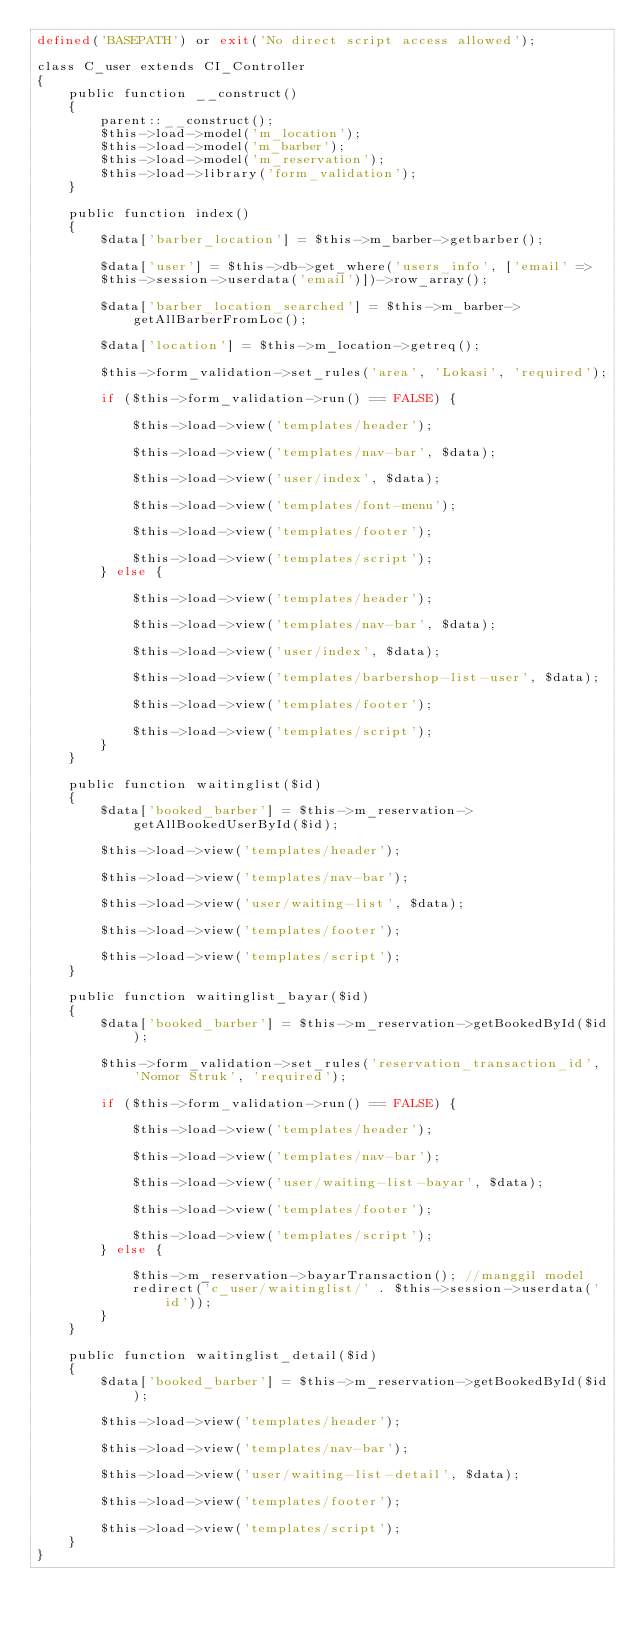<code> <loc_0><loc_0><loc_500><loc_500><_PHP_>defined('BASEPATH') or exit('No direct script access allowed');

class C_user extends CI_Controller
{
    public function __construct()
    {
        parent::__construct();
        $this->load->model('m_location');
        $this->load->model('m_barber');
        $this->load->model('m_reservation');
        $this->load->library('form_validation');
    }

    public function index()
    {
        $data['barber_location'] = $this->m_barber->getbarber();

        $data['user'] = $this->db->get_where('users_info', ['email' =>
        $this->session->userdata('email')])->row_array();

        $data['barber_location_searched'] = $this->m_barber->getAllBarberFromLoc();

        $data['location'] = $this->m_location->getreq();

        $this->form_validation->set_rules('area', 'Lokasi', 'required');

        if ($this->form_validation->run() == FALSE) {

            $this->load->view('templates/header');

            $this->load->view('templates/nav-bar', $data);

            $this->load->view('user/index', $data);

            $this->load->view('templates/font-menu');

            $this->load->view('templates/footer');

            $this->load->view('templates/script');
        } else {

            $this->load->view('templates/header');

            $this->load->view('templates/nav-bar', $data);

            $this->load->view('user/index', $data);

            $this->load->view('templates/barbershop-list-user', $data);

            $this->load->view('templates/footer');

            $this->load->view('templates/script');
        }
    }

    public function waitinglist($id)
    {
        $data['booked_barber'] = $this->m_reservation->getAllBookedUserById($id);

        $this->load->view('templates/header');

        $this->load->view('templates/nav-bar');

        $this->load->view('user/waiting-list', $data);

        $this->load->view('templates/footer');

        $this->load->view('templates/script');
    }

    public function waitinglist_bayar($id)
    {
        $data['booked_barber'] = $this->m_reservation->getBookedById($id);

        $this->form_validation->set_rules('reservation_transaction_id', 'Nomor Struk', 'required');

        if ($this->form_validation->run() == FALSE) {

            $this->load->view('templates/header');

            $this->load->view('templates/nav-bar');

            $this->load->view('user/waiting-list-bayar', $data);

            $this->load->view('templates/footer');

            $this->load->view('templates/script');
        } else {

            $this->m_reservation->bayarTransaction(); //manggil model
            redirect('c_user/waitinglist/' . $this->session->userdata('id'));
        }
    }

    public function waitinglist_detail($id)
    {
        $data['booked_barber'] = $this->m_reservation->getBookedById($id);

        $this->load->view('templates/header');

        $this->load->view('templates/nav-bar');

        $this->load->view('user/waiting-list-detail', $data);

        $this->load->view('templates/footer');

        $this->load->view('templates/script');
    }
}
</code> 